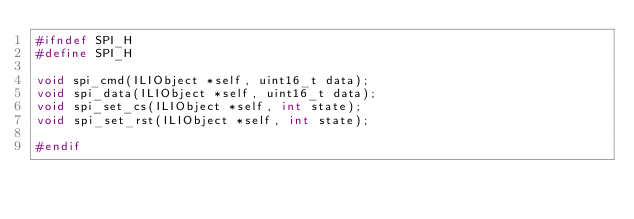<code> <loc_0><loc_0><loc_500><loc_500><_C_>#ifndef SPI_H
#define SPI_H

void spi_cmd(ILIObject *self, uint16_t data);
void spi_data(ILIObject *self, uint16_t data);
void spi_set_cs(ILIObject *self, int state);
void spi_set_rst(ILIObject *self, int state);

#endif</code> 